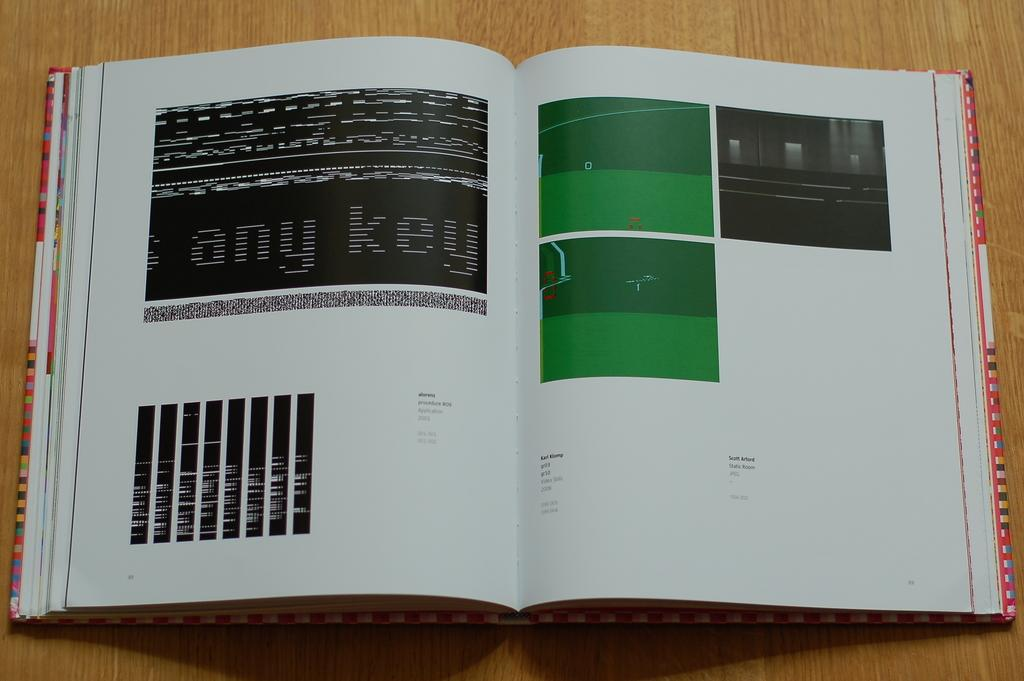<image>
Render a clear and concise summary of the photo. A book open to page 88 with the words "any key" in large print 